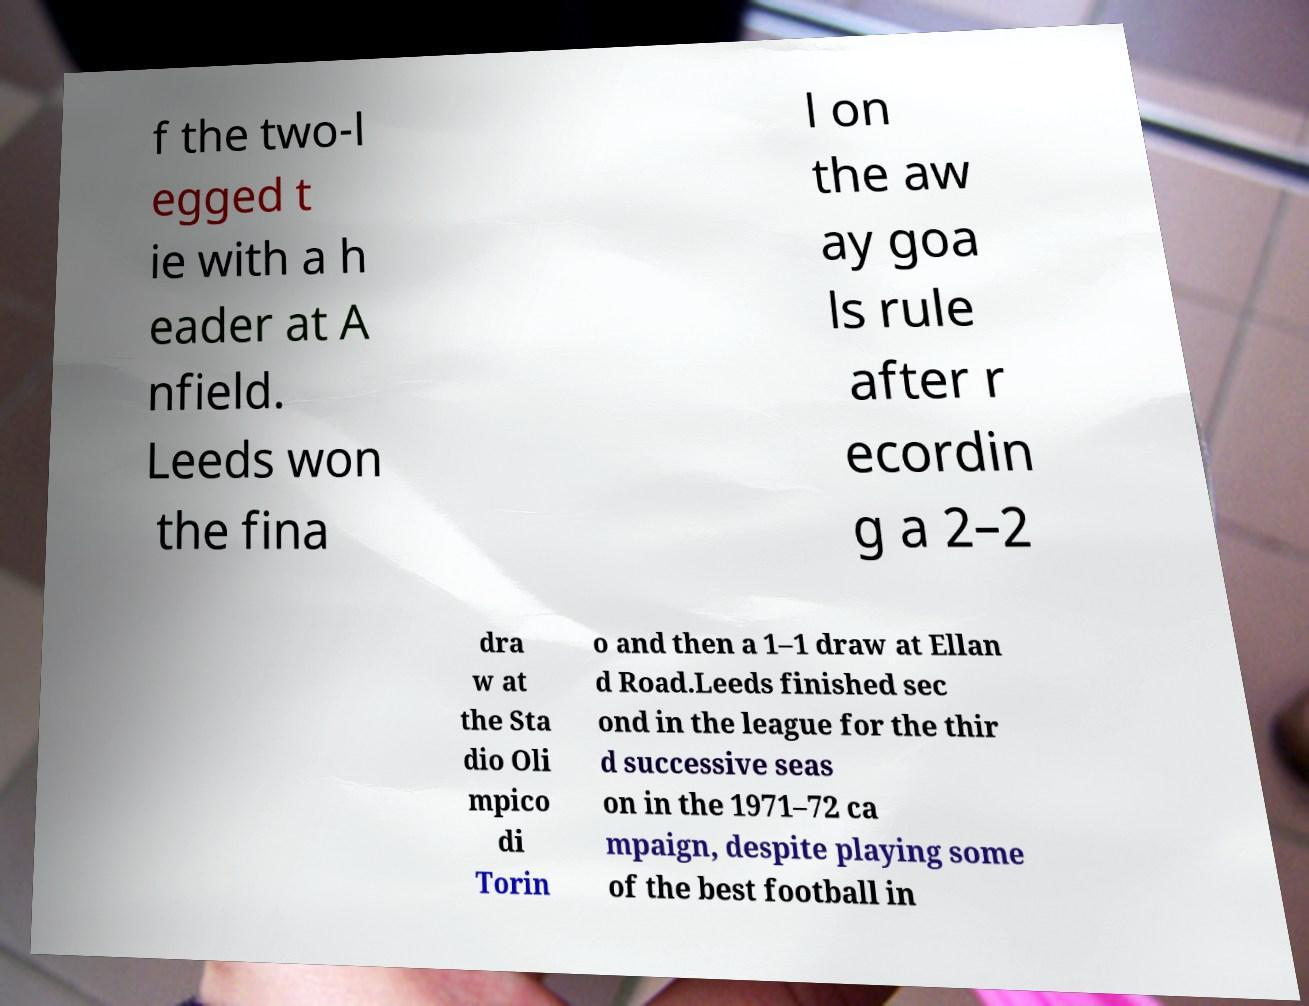Could you extract and type out the text from this image? f the two-l egged t ie with a h eader at A nfield. Leeds won the fina l on the aw ay goa ls rule after r ecordin g a 2–2 dra w at the Sta dio Oli mpico di Torin o and then a 1–1 draw at Ellan d Road.Leeds finished sec ond in the league for the thir d successive seas on in the 1971–72 ca mpaign, despite playing some of the best football in 